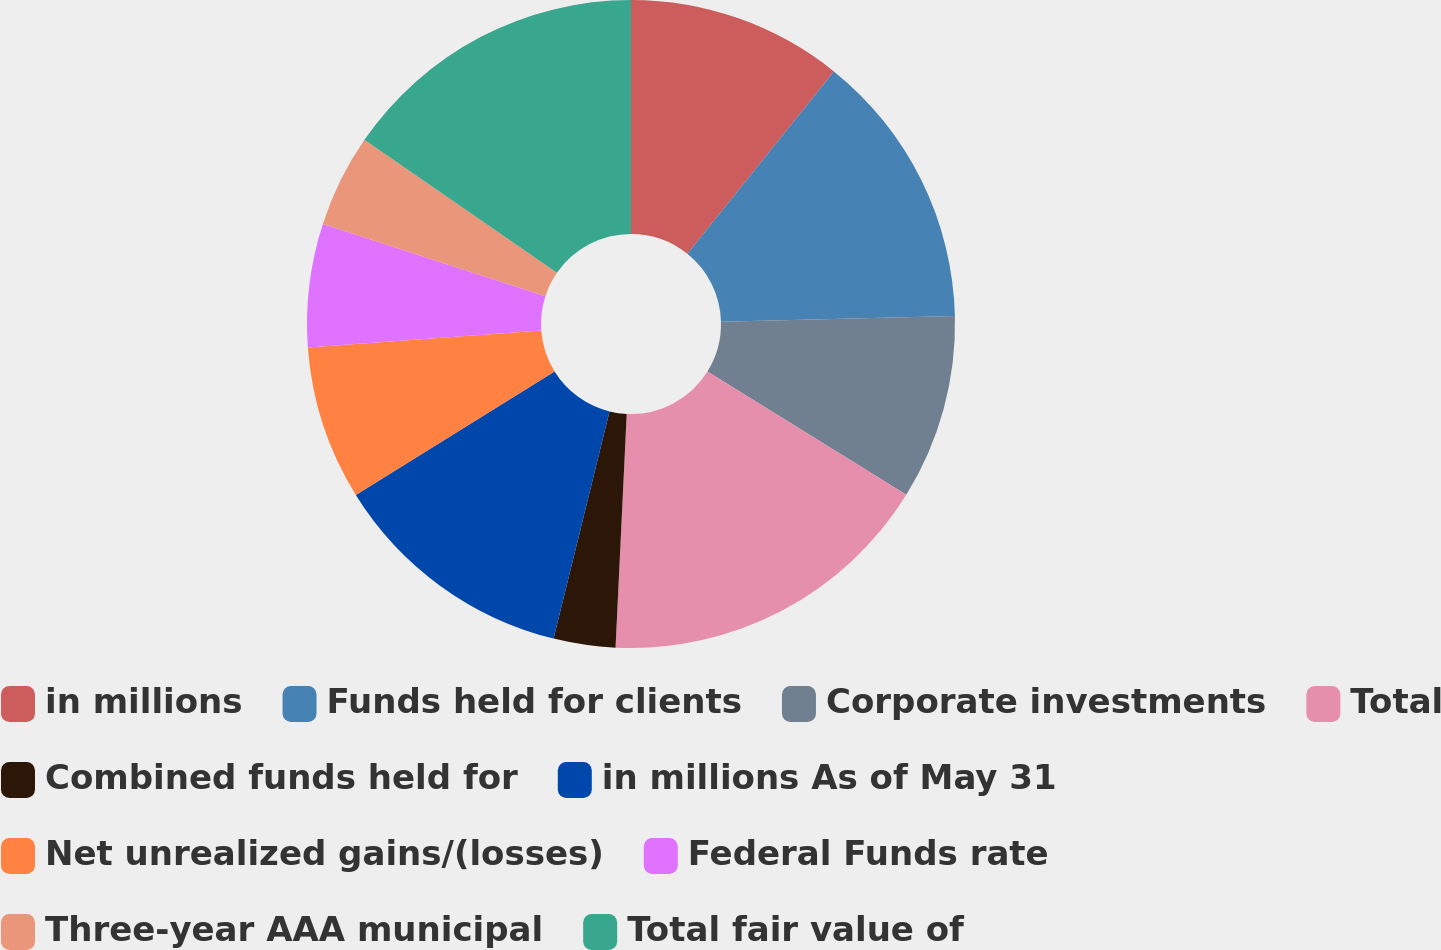<chart> <loc_0><loc_0><loc_500><loc_500><pie_chart><fcel>in millions<fcel>Funds held for clients<fcel>Corporate investments<fcel>Total<fcel>Combined funds held for<fcel>in millions As of May 31<fcel>Net unrealized gains/(losses)<fcel>Federal Funds rate<fcel>Three-year AAA municipal<fcel>Total fair value of<nl><fcel>10.77%<fcel>13.84%<fcel>9.23%<fcel>16.92%<fcel>3.08%<fcel>12.31%<fcel>7.69%<fcel>6.16%<fcel>4.62%<fcel>15.38%<nl></chart> 